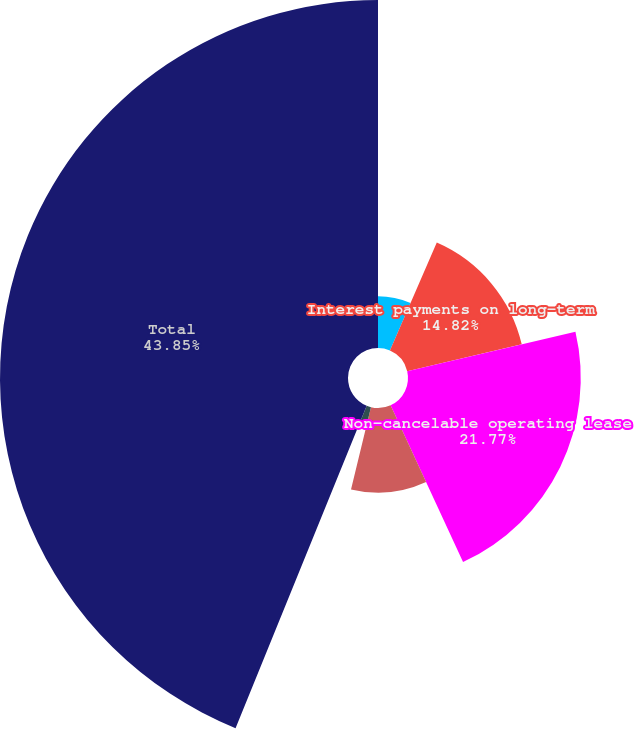<chart> <loc_0><loc_0><loc_500><loc_500><pie_chart><fcel>Long-term debt 1<fcel>Interest payments on long-term<fcel>Non-cancelable operating lease<fcel>Contingent acquisition<fcel>Uncertain tax positions<fcel>Total<nl><fcel>6.52%<fcel>14.82%<fcel>21.77%<fcel>10.67%<fcel>2.37%<fcel>43.85%<nl></chart> 